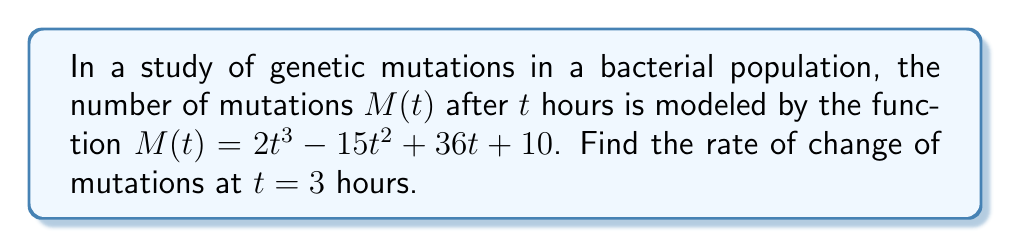Give your solution to this math problem. To find the rate of change of mutations at $t = 3$ hours, we need to calculate the derivative of $M(t)$ and evaluate it at $t = 3$. This will give us the slope of the tangent line to the curve at that point.

Step 1: Find the derivative of $M(t)$.
$$\frac{d}{dt}M(t) = \frac{d}{dt}(2t^3 - 15t^2 + 36t + 10)$$
$$M'(t) = 6t^2 - 30t + 36$$

Step 2: Evaluate $M'(t)$ at $t = 3$.
$$M'(3) = 6(3)^2 - 30(3) + 36$$
$$M'(3) = 6(9) - 90 + 36$$
$$M'(3) = 54 - 90 + 36$$
$$M'(3) = 0$$

Therefore, the rate of change of mutations at $t = 3$ hours is 0 mutations per hour.
Answer: 0 mutations/hour 